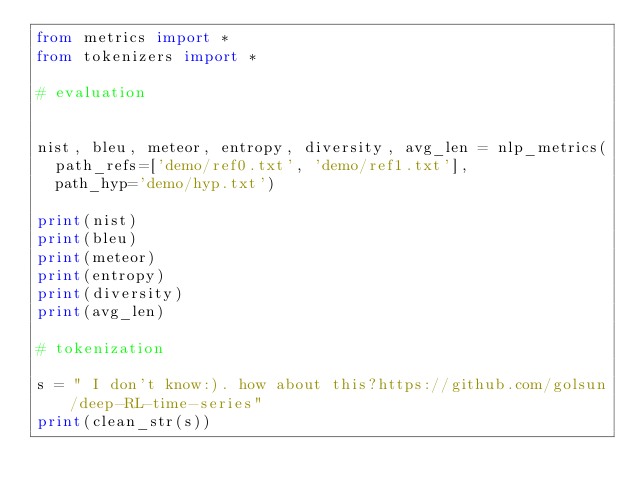<code> <loc_0><loc_0><loc_500><loc_500><_Python_>from metrics import *
from tokenizers import *

# evaluation


nist, bleu, meteor, entropy, diversity, avg_len = nlp_metrics(
	path_refs=['demo/ref0.txt', 'demo/ref1.txt'], 
	path_hyp='demo/hyp.txt')

print(nist)
print(bleu)
print(meteor)
print(entropy)
print(diversity)
print(avg_len)

# tokenization 

s = " I don't know:). how about this?https://github.com/golsun/deep-RL-time-series"
print(clean_str(s))
</code> 